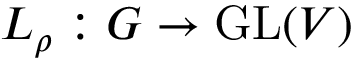<formula> <loc_0><loc_0><loc_500><loc_500>L _ { \rho } \colon G \to { G L } ( V )</formula> 